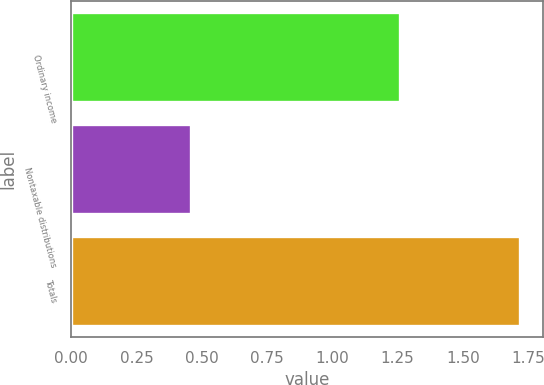Convert chart to OTSL. <chart><loc_0><loc_0><loc_500><loc_500><bar_chart><fcel>Ordinary income<fcel>Nontaxable distributions<fcel>Totals<nl><fcel>1.26<fcel>0.46<fcel>1.72<nl></chart> 